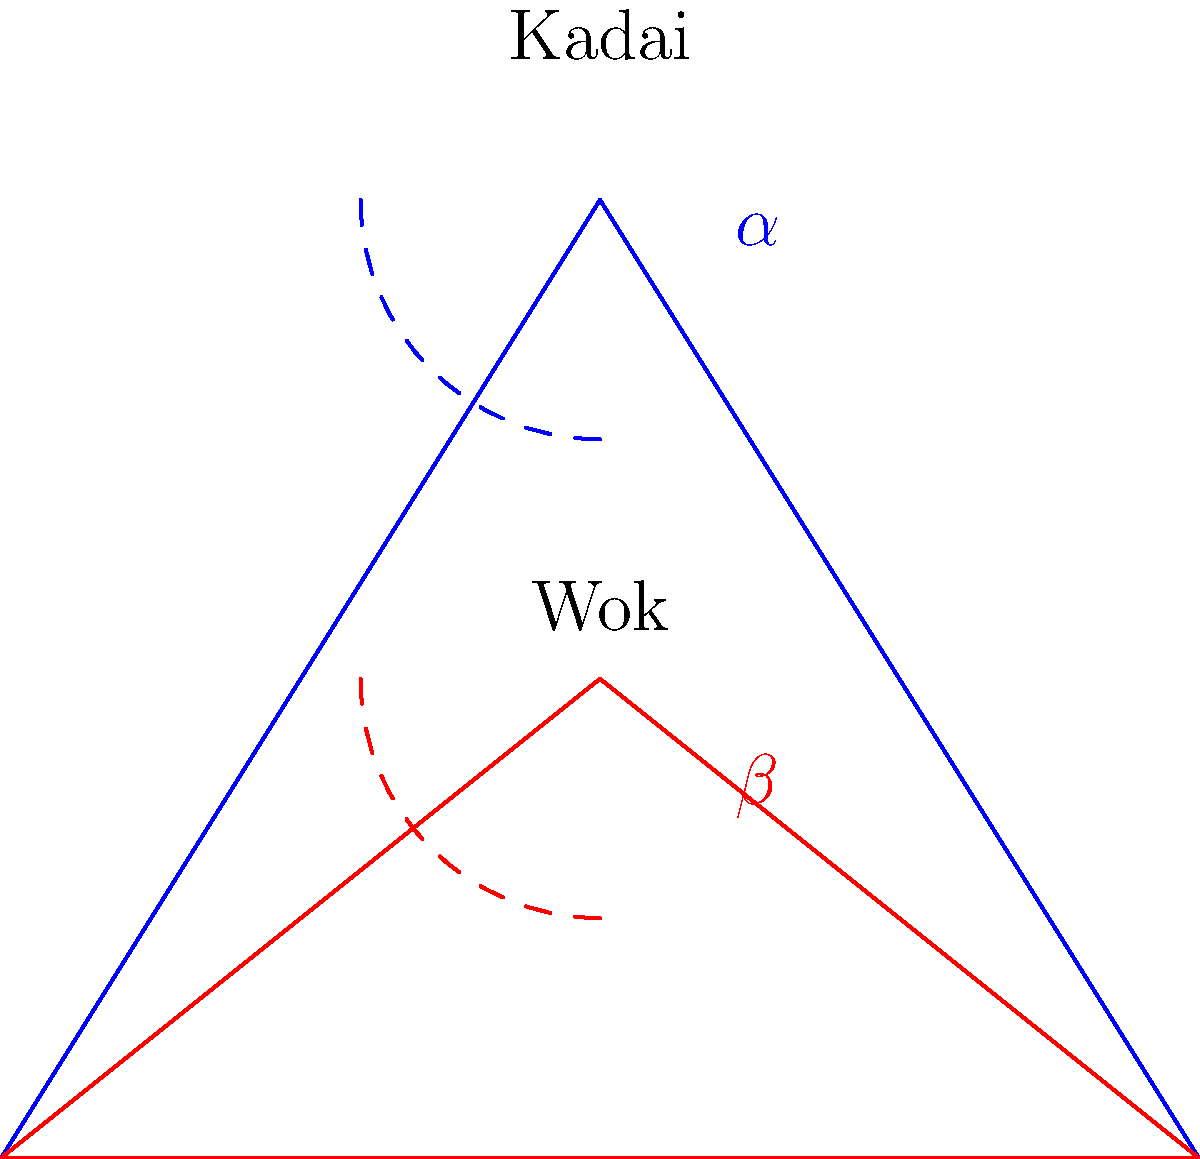Compare the angles of a traditional Indian kadai and a Chinese wok as shown in the diagram. How does the steeper angle ($\alpha$) of the kadai affect heat distribution compared to the shallower angle ($\beta$) of the wok? To understand how the angles of these cooking utensils affect heat distribution, let's follow these steps:

1. Kadai angle ($\alpha$):
   - The kadai has a steeper angle, typically around 60-70 degrees.
   - This steep angle creates a larger surface area in contact with the heat source.

2. Wok angle ($\beta$):
   - The wok has a shallower angle, usually around 45-50 degrees.
   - This results in a smaller surface area in direct contact with the heat source.

3. Heat distribution in a kadai:
   - The steeper angle allows for more even heat distribution across the bottom and sides.
   - Heat travels up the sides more gradually, creating distinct temperature zones.
   - This is ideal for slow cooking and simmering, as it allows for better control of the cooking process.

4. Heat distribution in a wok:
   - The shallower angle concentrates heat at the bottom center.
   - Heat distribution is less even, with a rapid temperature gradient from bottom to sides.
   - This is perfect for stir-frying, as it allows for quick cooking at the center and slower cooking on the sides.

5. Impact on Indian cooking:
   - The kadai's design suits many Indian dishes that require slow cooking or simmering.
   - It allows for better retention of moisture in curries and stews.
   - The even heat distribution helps in cooking dishes like biryani, where layering and consistent heat are crucial.

In summary, the steeper angle ($\alpha$) of the kadai provides more even heat distribution and better temperature control, which is ideal for the slow-cooking methods often used in Indian cuisine.
Answer: More even heat distribution, better for slow-cooking Indian dishes 